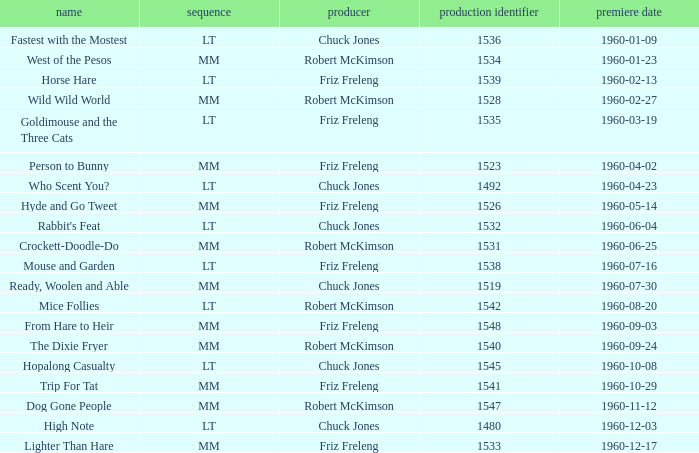What is the production number for the episode directed by Robert McKimson named Mice Follies? 1.0. 